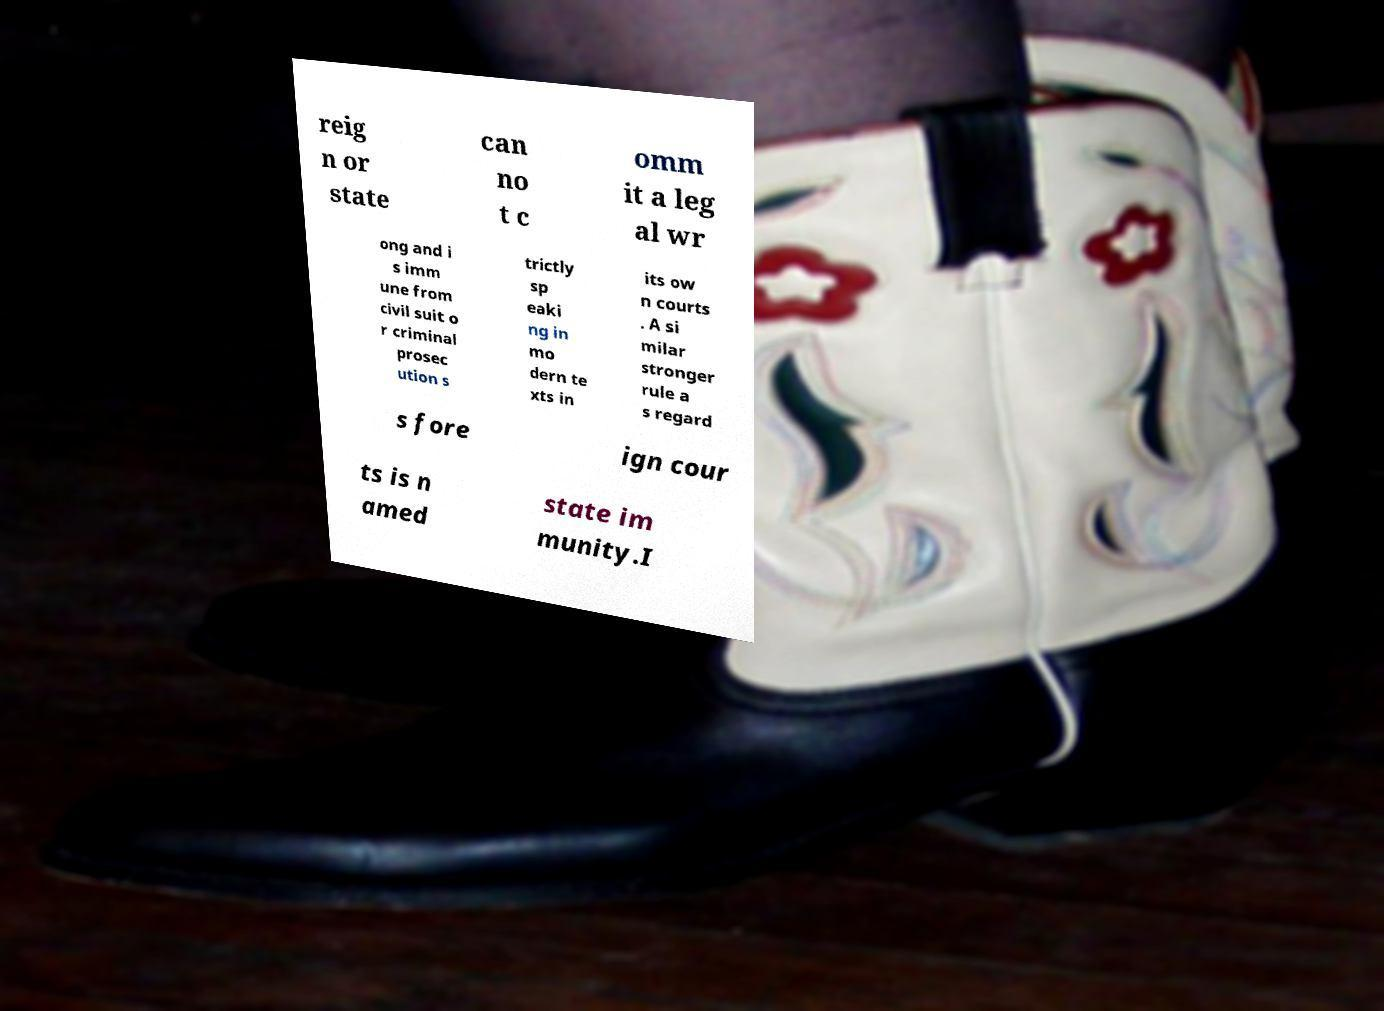Can you accurately transcribe the text from the provided image for me? reig n or state can no t c omm it a leg al wr ong and i s imm une from civil suit o r criminal prosec ution s trictly sp eaki ng in mo dern te xts in its ow n courts . A si milar stronger rule a s regard s fore ign cour ts is n amed state im munity.I 